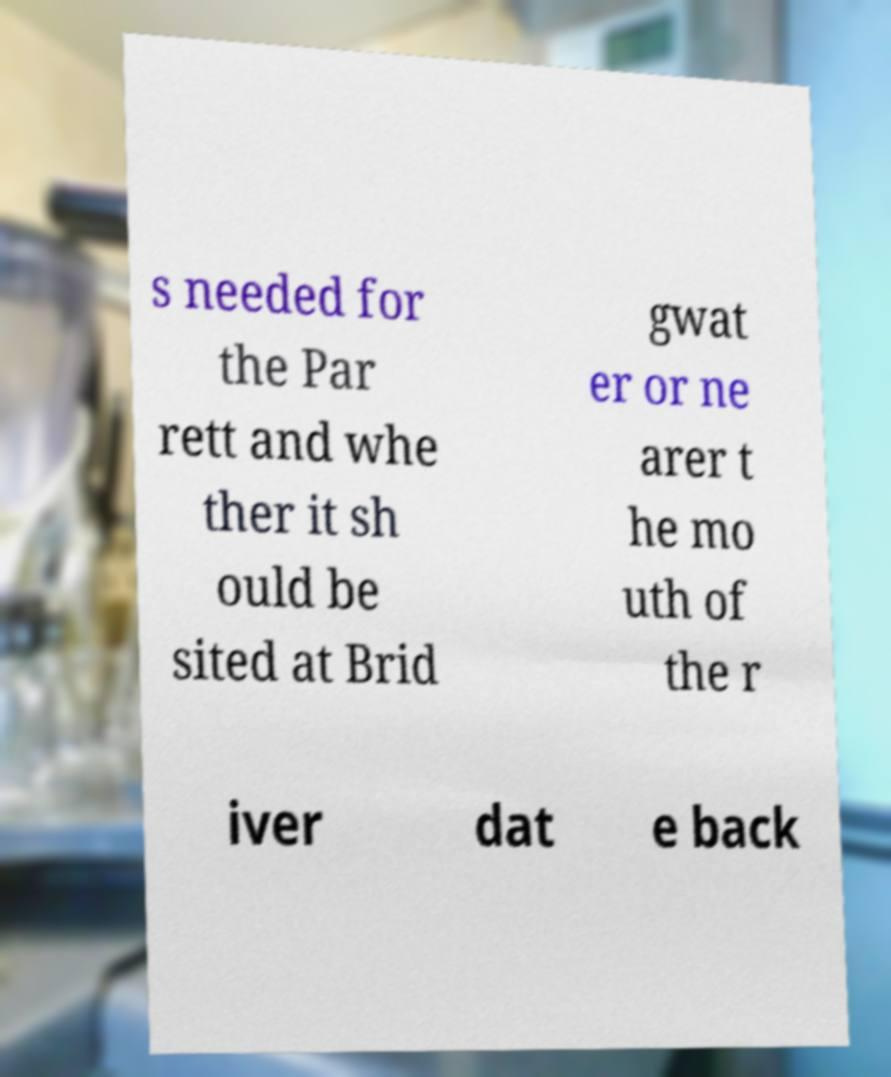Please identify and transcribe the text found in this image. s needed for the Par rett and whe ther it sh ould be sited at Brid gwat er or ne arer t he mo uth of the r iver dat e back 